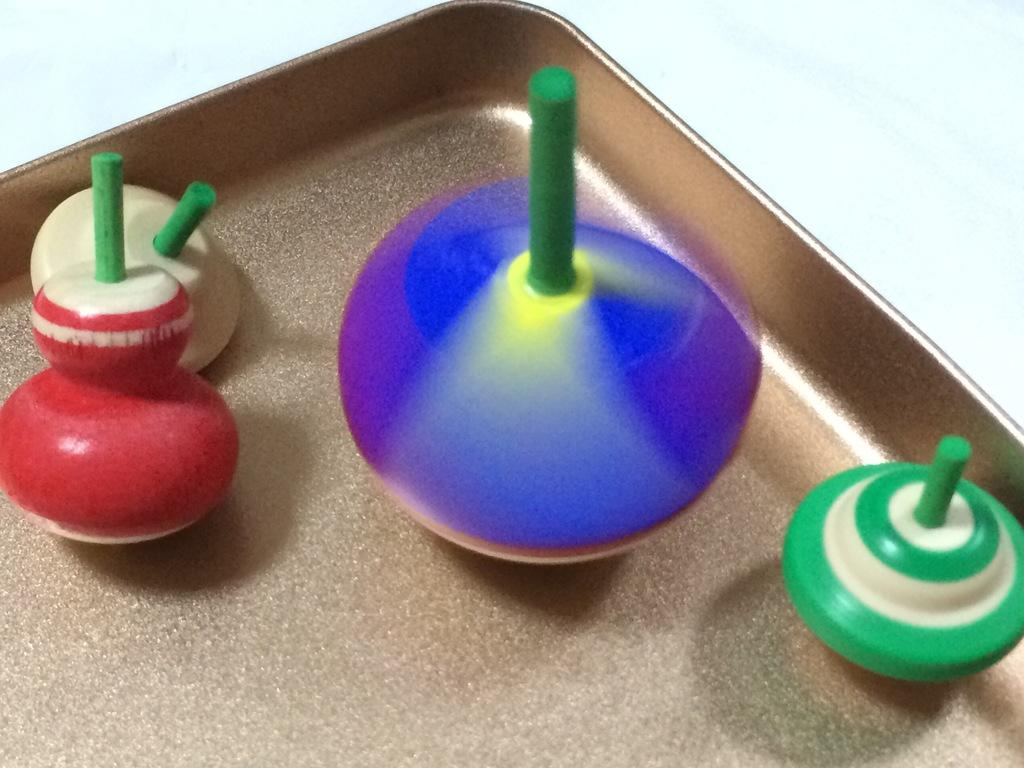What type of objects can be seen in the image? There are playing toys in the image. Can you describe the presence of any other objects in the image? Yes, there is a tray in the image. What type of potato is being used as a badge in the image? There is no potato or badge present in the image. 